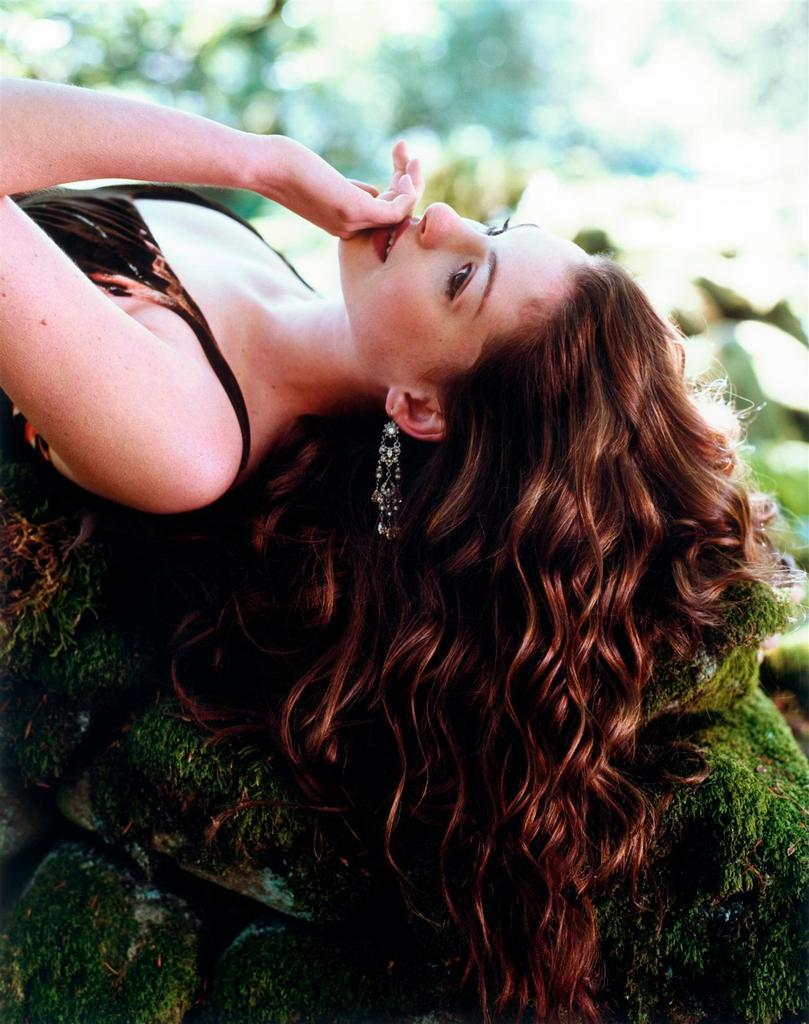What is the lady doing in the image? The lady is lying on the rocks in the image. What can be seen on the rocks besides the lady? There is algae on the rocks. Can you describe the background of the image? The background of the image is blurred. What type of waste can be seen in the lady's stomach in the image? There is no waste visible in the lady's stomach in the image, nor is there any indication that the lady's stomach is visible. What type of glove is the lady wearing in the image? There is no glove visible on the lady in the image. 